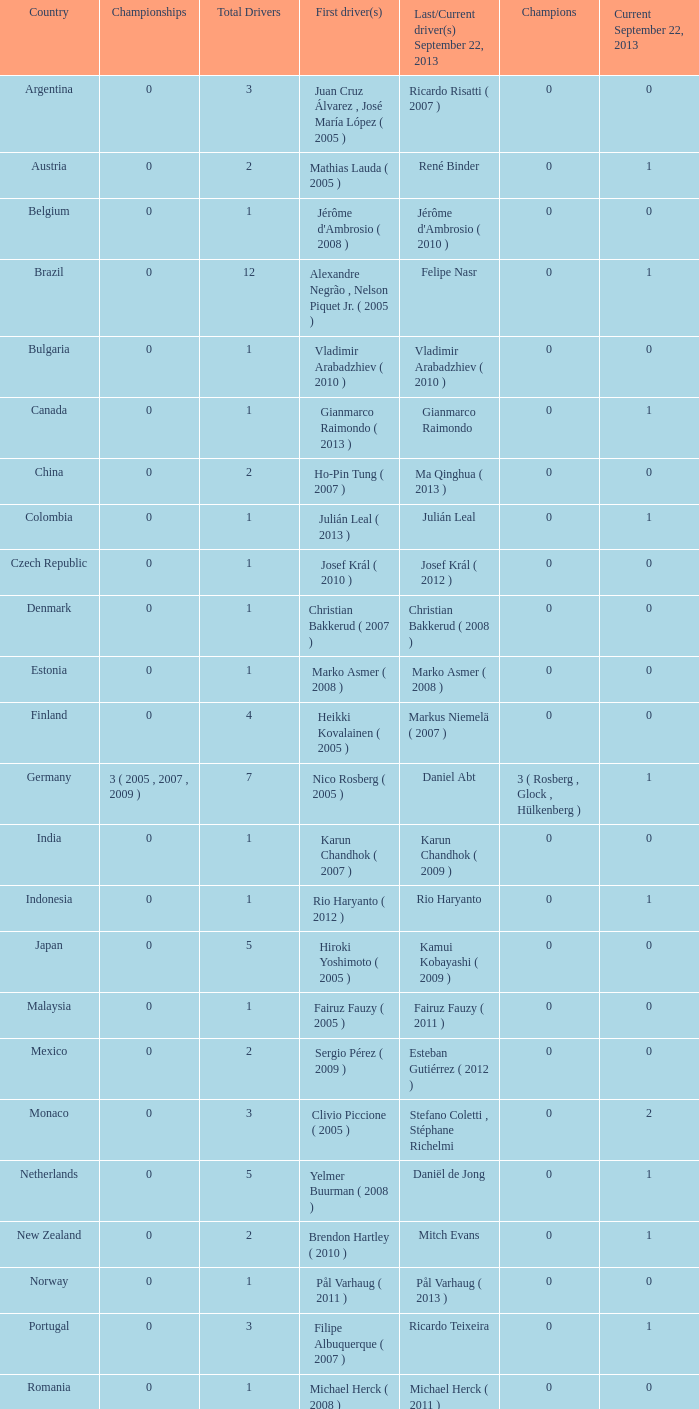How many entries are there for total drivers when the Last driver for september 22, 2013 was gianmarco raimondo? 1.0. 